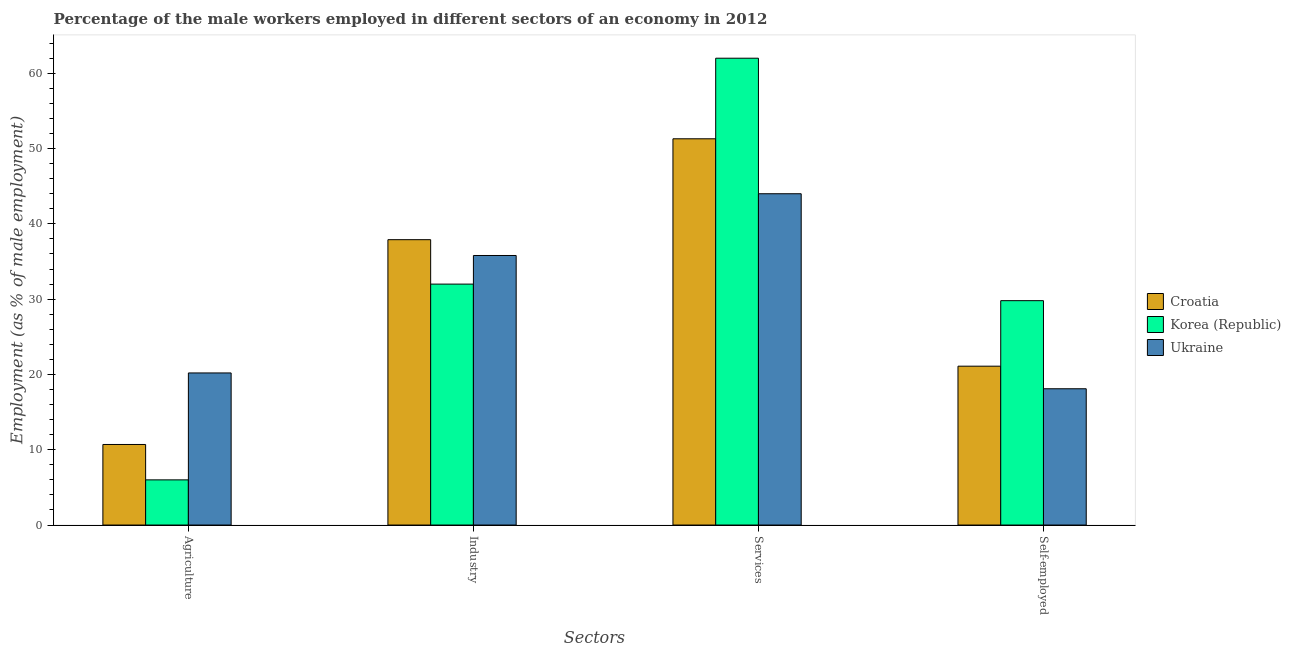Are the number of bars per tick equal to the number of legend labels?
Offer a very short reply. Yes. Are the number of bars on each tick of the X-axis equal?
Provide a short and direct response. Yes. What is the label of the 2nd group of bars from the left?
Your response must be concise. Industry. What is the percentage of male workers in services in Ukraine?
Provide a short and direct response. 44. Across all countries, what is the maximum percentage of self employed male workers?
Provide a short and direct response. 29.8. In which country was the percentage of male workers in agriculture maximum?
Your answer should be compact. Ukraine. In which country was the percentage of male workers in industry minimum?
Your answer should be very brief. Korea (Republic). What is the total percentage of male workers in industry in the graph?
Offer a very short reply. 105.7. What is the difference between the percentage of male workers in services in Ukraine and that in Croatia?
Provide a short and direct response. -7.3. What is the difference between the percentage of self employed male workers in Ukraine and the percentage of male workers in industry in Korea (Republic)?
Your answer should be compact. -13.9. What is the average percentage of male workers in agriculture per country?
Your answer should be compact. 12.3. What is the difference between the percentage of male workers in services and percentage of male workers in agriculture in Ukraine?
Offer a terse response. 23.8. In how many countries, is the percentage of male workers in agriculture greater than 34 %?
Your response must be concise. 0. What is the ratio of the percentage of male workers in industry in Croatia to that in Korea (Republic)?
Ensure brevity in your answer.  1.18. Is the difference between the percentage of male workers in services in Croatia and Korea (Republic) greater than the difference between the percentage of self employed male workers in Croatia and Korea (Republic)?
Your response must be concise. No. What is the difference between the highest and the second highest percentage of male workers in services?
Provide a short and direct response. 10.7. Is it the case that in every country, the sum of the percentage of self employed male workers and percentage of male workers in agriculture is greater than the sum of percentage of male workers in services and percentage of male workers in industry?
Offer a very short reply. No. What does the 1st bar from the left in Self-employed represents?
Make the answer very short. Croatia. What does the 3rd bar from the right in Industry represents?
Provide a succinct answer. Croatia. Is it the case that in every country, the sum of the percentage of male workers in agriculture and percentage of male workers in industry is greater than the percentage of male workers in services?
Offer a very short reply. No. How many bars are there?
Provide a succinct answer. 12. Are all the bars in the graph horizontal?
Your answer should be compact. No. What is the difference between two consecutive major ticks on the Y-axis?
Provide a short and direct response. 10. Are the values on the major ticks of Y-axis written in scientific E-notation?
Offer a terse response. No. Does the graph contain any zero values?
Make the answer very short. No. Does the graph contain grids?
Offer a very short reply. No. What is the title of the graph?
Make the answer very short. Percentage of the male workers employed in different sectors of an economy in 2012. What is the label or title of the X-axis?
Provide a short and direct response. Sectors. What is the label or title of the Y-axis?
Your response must be concise. Employment (as % of male employment). What is the Employment (as % of male employment) in Croatia in Agriculture?
Keep it short and to the point. 10.7. What is the Employment (as % of male employment) of Korea (Republic) in Agriculture?
Your answer should be compact. 6. What is the Employment (as % of male employment) of Ukraine in Agriculture?
Offer a very short reply. 20.2. What is the Employment (as % of male employment) in Croatia in Industry?
Make the answer very short. 37.9. What is the Employment (as % of male employment) in Korea (Republic) in Industry?
Provide a short and direct response. 32. What is the Employment (as % of male employment) of Ukraine in Industry?
Your answer should be compact. 35.8. What is the Employment (as % of male employment) of Croatia in Services?
Ensure brevity in your answer.  51.3. What is the Employment (as % of male employment) of Croatia in Self-employed?
Your response must be concise. 21.1. What is the Employment (as % of male employment) in Korea (Republic) in Self-employed?
Offer a terse response. 29.8. What is the Employment (as % of male employment) of Ukraine in Self-employed?
Give a very brief answer. 18.1. Across all Sectors, what is the maximum Employment (as % of male employment) of Croatia?
Your answer should be very brief. 51.3. Across all Sectors, what is the maximum Employment (as % of male employment) in Korea (Republic)?
Your answer should be very brief. 62. Across all Sectors, what is the maximum Employment (as % of male employment) of Ukraine?
Provide a short and direct response. 44. Across all Sectors, what is the minimum Employment (as % of male employment) in Croatia?
Your answer should be compact. 10.7. Across all Sectors, what is the minimum Employment (as % of male employment) of Korea (Republic)?
Ensure brevity in your answer.  6. Across all Sectors, what is the minimum Employment (as % of male employment) of Ukraine?
Your answer should be very brief. 18.1. What is the total Employment (as % of male employment) of Croatia in the graph?
Your answer should be very brief. 121. What is the total Employment (as % of male employment) in Korea (Republic) in the graph?
Provide a succinct answer. 129.8. What is the total Employment (as % of male employment) of Ukraine in the graph?
Your answer should be compact. 118.1. What is the difference between the Employment (as % of male employment) in Croatia in Agriculture and that in Industry?
Your answer should be compact. -27.2. What is the difference between the Employment (as % of male employment) of Ukraine in Agriculture and that in Industry?
Give a very brief answer. -15.6. What is the difference between the Employment (as % of male employment) of Croatia in Agriculture and that in Services?
Keep it short and to the point. -40.6. What is the difference between the Employment (as % of male employment) in Korea (Republic) in Agriculture and that in Services?
Provide a succinct answer. -56. What is the difference between the Employment (as % of male employment) of Ukraine in Agriculture and that in Services?
Your answer should be very brief. -23.8. What is the difference between the Employment (as % of male employment) of Croatia in Agriculture and that in Self-employed?
Give a very brief answer. -10.4. What is the difference between the Employment (as % of male employment) of Korea (Republic) in Agriculture and that in Self-employed?
Offer a terse response. -23.8. What is the difference between the Employment (as % of male employment) of Croatia in Industry and that in Services?
Offer a terse response. -13.4. What is the difference between the Employment (as % of male employment) of Ukraine in Industry and that in Services?
Give a very brief answer. -8.2. What is the difference between the Employment (as % of male employment) in Croatia in Services and that in Self-employed?
Ensure brevity in your answer.  30.2. What is the difference between the Employment (as % of male employment) of Korea (Republic) in Services and that in Self-employed?
Your answer should be compact. 32.2. What is the difference between the Employment (as % of male employment) in Ukraine in Services and that in Self-employed?
Provide a short and direct response. 25.9. What is the difference between the Employment (as % of male employment) in Croatia in Agriculture and the Employment (as % of male employment) in Korea (Republic) in Industry?
Provide a short and direct response. -21.3. What is the difference between the Employment (as % of male employment) in Croatia in Agriculture and the Employment (as % of male employment) in Ukraine in Industry?
Give a very brief answer. -25.1. What is the difference between the Employment (as % of male employment) of Korea (Republic) in Agriculture and the Employment (as % of male employment) of Ukraine in Industry?
Your answer should be compact. -29.8. What is the difference between the Employment (as % of male employment) of Croatia in Agriculture and the Employment (as % of male employment) of Korea (Republic) in Services?
Provide a short and direct response. -51.3. What is the difference between the Employment (as % of male employment) in Croatia in Agriculture and the Employment (as % of male employment) in Ukraine in Services?
Your answer should be compact. -33.3. What is the difference between the Employment (as % of male employment) of Korea (Republic) in Agriculture and the Employment (as % of male employment) of Ukraine in Services?
Provide a succinct answer. -38. What is the difference between the Employment (as % of male employment) in Croatia in Agriculture and the Employment (as % of male employment) in Korea (Republic) in Self-employed?
Ensure brevity in your answer.  -19.1. What is the difference between the Employment (as % of male employment) of Korea (Republic) in Agriculture and the Employment (as % of male employment) of Ukraine in Self-employed?
Your response must be concise. -12.1. What is the difference between the Employment (as % of male employment) in Croatia in Industry and the Employment (as % of male employment) in Korea (Republic) in Services?
Offer a very short reply. -24.1. What is the difference between the Employment (as % of male employment) in Croatia in Industry and the Employment (as % of male employment) in Ukraine in Services?
Provide a short and direct response. -6.1. What is the difference between the Employment (as % of male employment) of Korea (Republic) in Industry and the Employment (as % of male employment) of Ukraine in Services?
Give a very brief answer. -12. What is the difference between the Employment (as % of male employment) of Croatia in Industry and the Employment (as % of male employment) of Ukraine in Self-employed?
Offer a terse response. 19.8. What is the difference between the Employment (as % of male employment) in Korea (Republic) in Industry and the Employment (as % of male employment) in Ukraine in Self-employed?
Your answer should be very brief. 13.9. What is the difference between the Employment (as % of male employment) of Croatia in Services and the Employment (as % of male employment) of Korea (Republic) in Self-employed?
Give a very brief answer. 21.5. What is the difference between the Employment (as % of male employment) in Croatia in Services and the Employment (as % of male employment) in Ukraine in Self-employed?
Offer a terse response. 33.2. What is the difference between the Employment (as % of male employment) of Korea (Republic) in Services and the Employment (as % of male employment) of Ukraine in Self-employed?
Provide a succinct answer. 43.9. What is the average Employment (as % of male employment) of Croatia per Sectors?
Provide a succinct answer. 30.25. What is the average Employment (as % of male employment) of Korea (Republic) per Sectors?
Your answer should be compact. 32.45. What is the average Employment (as % of male employment) of Ukraine per Sectors?
Give a very brief answer. 29.52. What is the difference between the Employment (as % of male employment) of Croatia and Employment (as % of male employment) of Korea (Republic) in Agriculture?
Make the answer very short. 4.7. What is the difference between the Employment (as % of male employment) of Croatia and Employment (as % of male employment) of Ukraine in Agriculture?
Keep it short and to the point. -9.5. What is the difference between the Employment (as % of male employment) in Korea (Republic) and Employment (as % of male employment) in Ukraine in Industry?
Make the answer very short. -3.8. What is the difference between the Employment (as % of male employment) of Croatia and Employment (as % of male employment) of Ukraine in Services?
Offer a very short reply. 7.3. What is the difference between the Employment (as % of male employment) in Croatia and Employment (as % of male employment) in Ukraine in Self-employed?
Your answer should be compact. 3. What is the difference between the Employment (as % of male employment) in Korea (Republic) and Employment (as % of male employment) in Ukraine in Self-employed?
Give a very brief answer. 11.7. What is the ratio of the Employment (as % of male employment) of Croatia in Agriculture to that in Industry?
Keep it short and to the point. 0.28. What is the ratio of the Employment (as % of male employment) in Korea (Republic) in Agriculture to that in Industry?
Your answer should be compact. 0.19. What is the ratio of the Employment (as % of male employment) in Ukraine in Agriculture to that in Industry?
Make the answer very short. 0.56. What is the ratio of the Employment (as % of male employment) in Croatia in Agriculture to that in Services?
Your response must be concise. 0.21. What is the ratio of the Employment (as % of male employment) in Korea (Republic) in Agriculture to that in Services?
Make the answer very short. 0.1. What is the ratio of the Employment (as % of male employment) in Ukraine in Agriculture to that in Services?
Offer a very short reply. 0.46. What is the ratio of the Employment (as % of male employment) of Croatia in Agriculture to that in Self-employed?
Keep it short and to the point. 0.51. What is the ratio of the Employment (as % of male employment) in Korea (Republic) in Agriculture to that in Self-employed?
Provide a short and direct response. 0.2. What is the ratio of the Employment (as % of male employment) of Ukraine in Agriculture to that in Self-employed?
Provide a short and direct response. 1.12. What is the ratio of the Employment (as % of male employment) in Croatia in Industry to that in Services?
Provide a succinct answer. 0.74. What is the ratio of the Employment (as % of male employment) of Korea (Republic) in Industry to that in Services?
Give a very brief answer. 0.52. What is the ratio of the Employment (as % of male employment) in Ukraine in Industry to that in Services?
Ensure brevity in your answer.  0.81. What is the ratio of the Employment (as % of male employment) of Croatia in Industry to that in Self-employed?
Keep it short and to the point. 1.8. What is the ratio of the Employment (as % of male employment) in Korea (Republic) in Industry to that in Self-employed?
Your response must be concise. 1.07. What is the ratio of the Employment (as % of male employment) in Ukraine in Industry to that in Self-employed?
Your response must be concise. 1.98. What is the ratio of the Employment (as % of male employment) in Croatia in Services to that in Self-employed?
Your response must be concise. 2.43. What is the ratio of the Employment (as % of male employment) of Korea (Republic) in Services to that in Self-employed?
Provide a succinct answer. 2.08. What is the ratio of the Employment (as % of male employment) of Ukraine in Services to that in Self-employed?
Keep it short and to the point. 2.43. What is the difference between the highest and the second highest Employment (as % of male employment) of Korea (Republic)?
Make the answer very short. 30. What is the difference between the highest and the lowest Employment (as % of male employment) of Croatia?
Offer a terse response. 40.6. What is the difference between the highest and the lowest Employment (as % of male employment) in Ukraine?
Offer a very short reply. 25.9. 